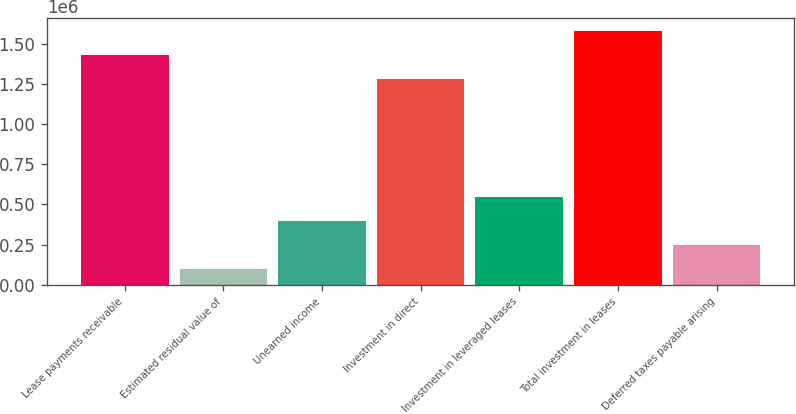<chart> <loc_0><loc_0><loc_500><loc_500><bar_chart><fcel>Lease payments receivable<fcel>Estimated residual value of<fcel>Unearned income<fcel>Investment in direct<fcel>Investment in leveraged leases<fcel>Total investment in leases<fcel>Deferred taxes payable arising<nl><fcel>1.42928e+06<fcel>99968<fcel>395655<fcel>1.28144e+06<fcel>543498<fcel>1.5784e+06<fcel>247811<nl></chart> 